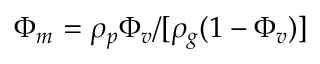Convert formula to latex. <formula><loc_0><loc_0><loc_500><loc_500>\Phi _ { m } = \rho _ { p } \Phi _ { v } / [ \rho _ { g } ( 1 - \Phi _ { v } ) ]</formula> 